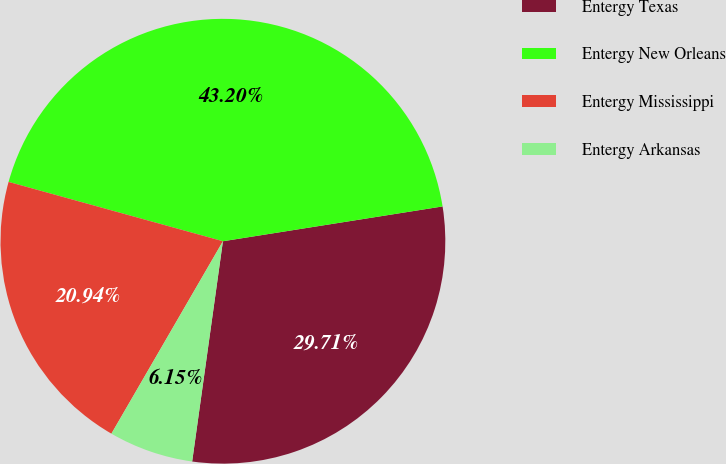Convert chart. <chart><loc_0><loc_0><loc_500><loc_500><pie_chart><fcel>Entergy Texas<fcel>Entergy New Orleans<fcel>Entergy Mississippi<fcel>Entergy Arkansas<nl><fcel>29.71%<fcel>43.2%<fcel>20.94%<fcel>6.15%<nl></chart> 